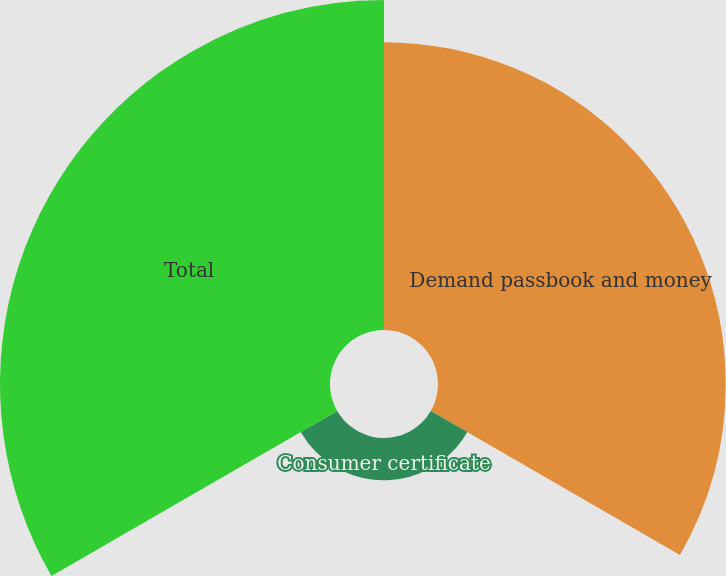<chart> <loc_0><loc_0><loc_500><loc_500><pie_chart><fcel>Demand passbook and money<fcel>Consumer certificate<fcel>Total<nl><fcel>43.6%<fcel>6.4%<fcel>50.0%<nl></chart> 